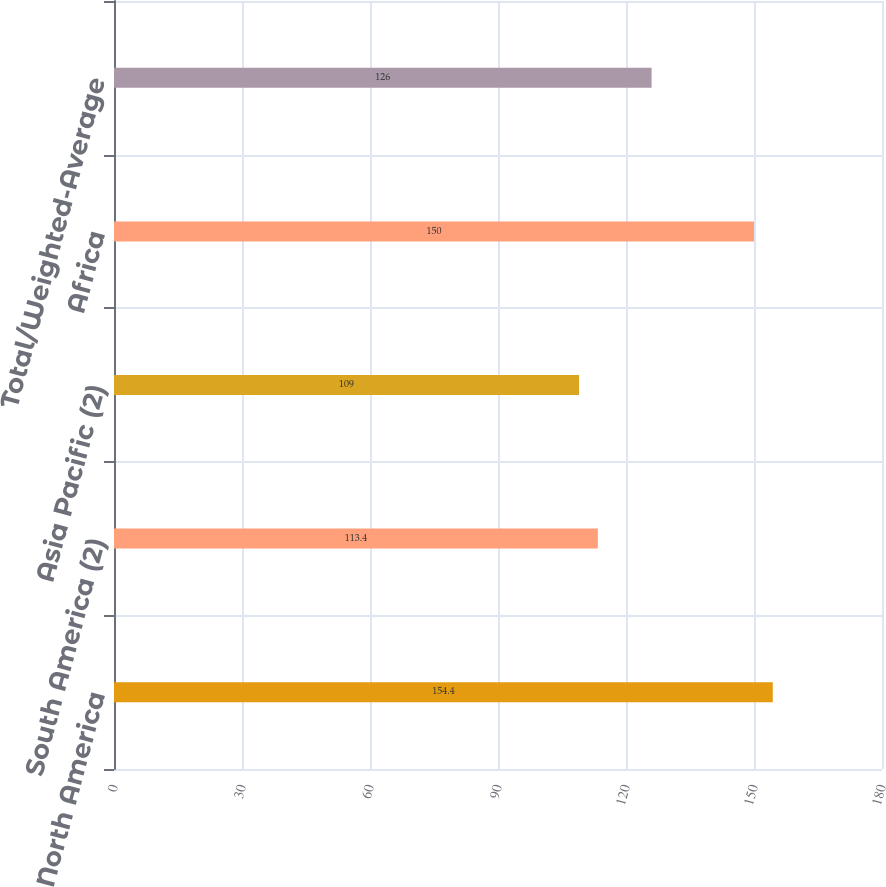<chart> <loc_0><loc_0><loc_500><loc_500><bar_chart><fcel>North America<fcel>South America (2)<fcel>Asia Pacific (2)<fcel>Africa<fcel>Total/Weighted-Average<nl><fcel>154.4<fcel>113.4<fcel>109<fcel>150<fcel>126<nl></chart> 